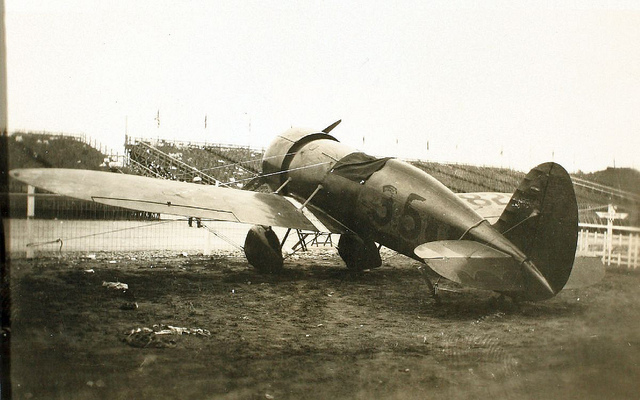Identify the text displayed in this image. 35 